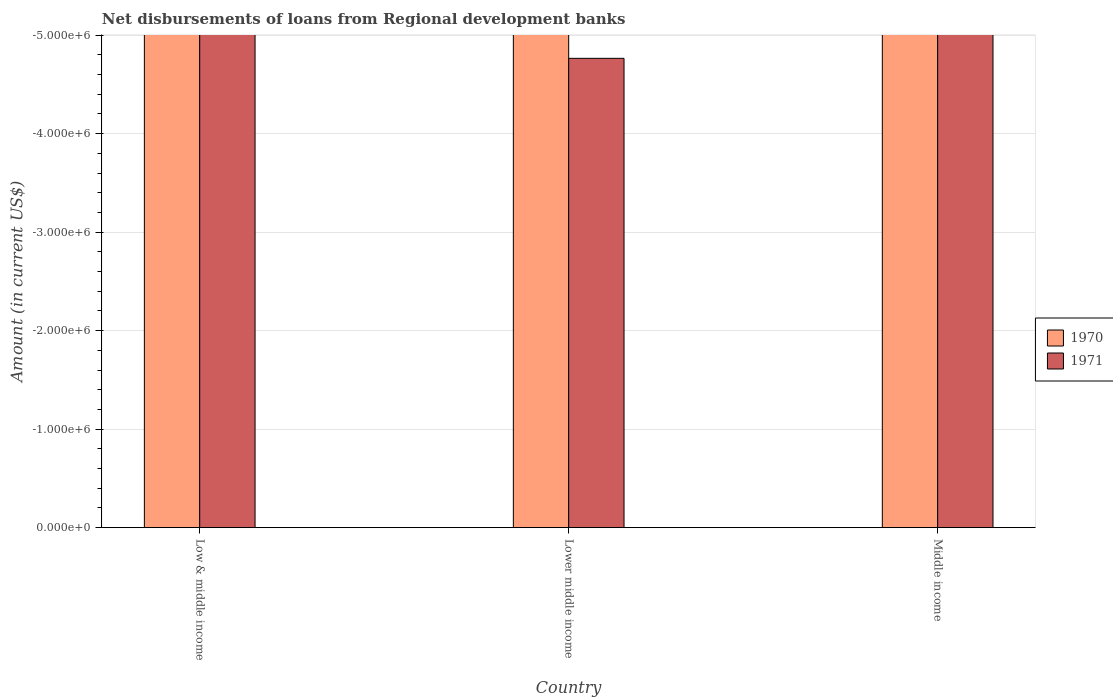What is the amount of disbursements of loans from regional development banks in 1970 in Middle income?
Your answer should be very brief. 0. What is the average amount of disbursements of loans from regional development banks in 1971 per country?
Make the answer very short. 0. In how many countries, is the amount of disbursements of loans from regional development banks in 1971 greater than -1600000 US$?
Your answer should be compact. 0. In how many countries, is the amount of disbursements of loans from regional development banks in 1970 greater than the average amount of disbursements of loans from regional development banks in 1970 taken over all countries?
Provide a succinct answer. 0. How many bars are there?
Your answer should be very brief. 0. What is the difference between two consecutive major ticks on the Y-axis?
Keep it short and to the point. 1.00e+06. Are the values on the major ticks of Y-axis written in scientific E-notation?
Offer a terse response. Yes. Where does the legend appear in the graph?
Give a very brief answer. Center right. How many legend labels are there?
Make the answer very short. 2. How are the legend labels stacked?
Make the answer very short. Vertical. What is the title of the graph?
Give a very brief answer. Net disbursements of loans from Regional development banks. Does "1987" appear as one of the legend labels in the graph?
Your response must be concise. No. What is the label or title of the X-axis?
Your answer should be very brief. Country. What is the label or title of the Y-axis?
Your answer should be compact. Amount (in current US$). What is the Amount (in current US$) in 1970 in Lower middle income?
Provide a short and direct response. 0. What is the Amount (in current US$) in 1970 in Middle income?
Make the answer very short. 0. What is the average Amount (in current US$) in 1970 per country?
Your response must be concise. 0. What is the average Amount (in current US$) of 1971 per country?
Provide a short and direct response. 0. 